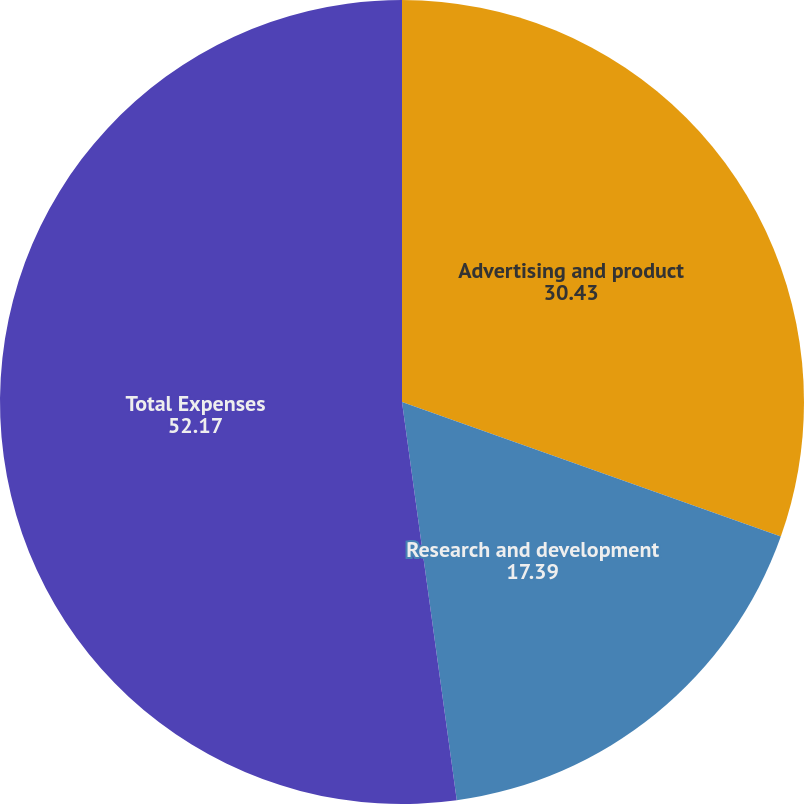Convert chart. <chart><loc_0><loc_0><loc_500><loc_500><pie_chart><fcel>Advertising and product<fcel>Research and development<fcel>Total Expenses<nl><fcel>30.43%<fcel>17.39%<fcel>52.17%<nl></chart> 